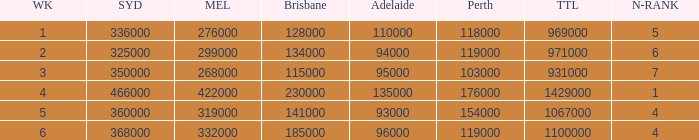What was the rating for Brisbane the week that Adelaide had 94000? 134000.0. 